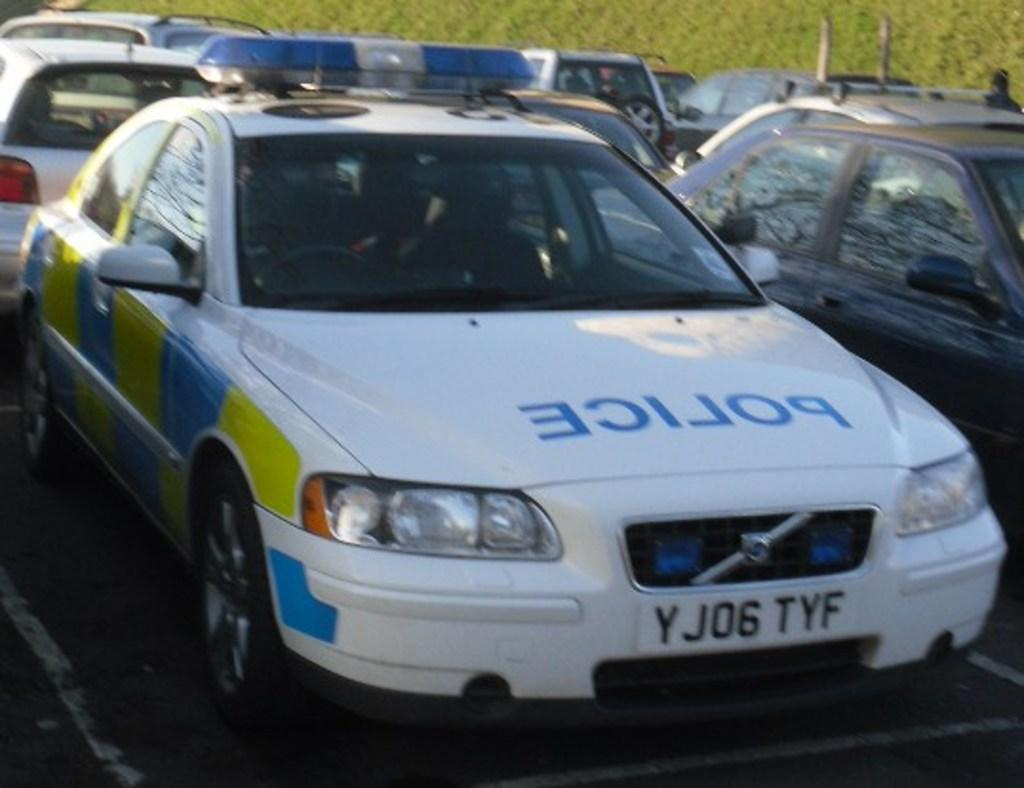Where was the image taken? The image was taken outdoors. What can be seen in the background of the image? There are plants in the background of the image. What is at the bottom of the image? There is a road at the bottom of the image. What is happening on the road in the middle of the image? Many cars are parked on the road in the middle of the image. What type of pen can be seen floating in the sky in the image? There is no pen visible in the image, and the sky does not contain any floating objects. 